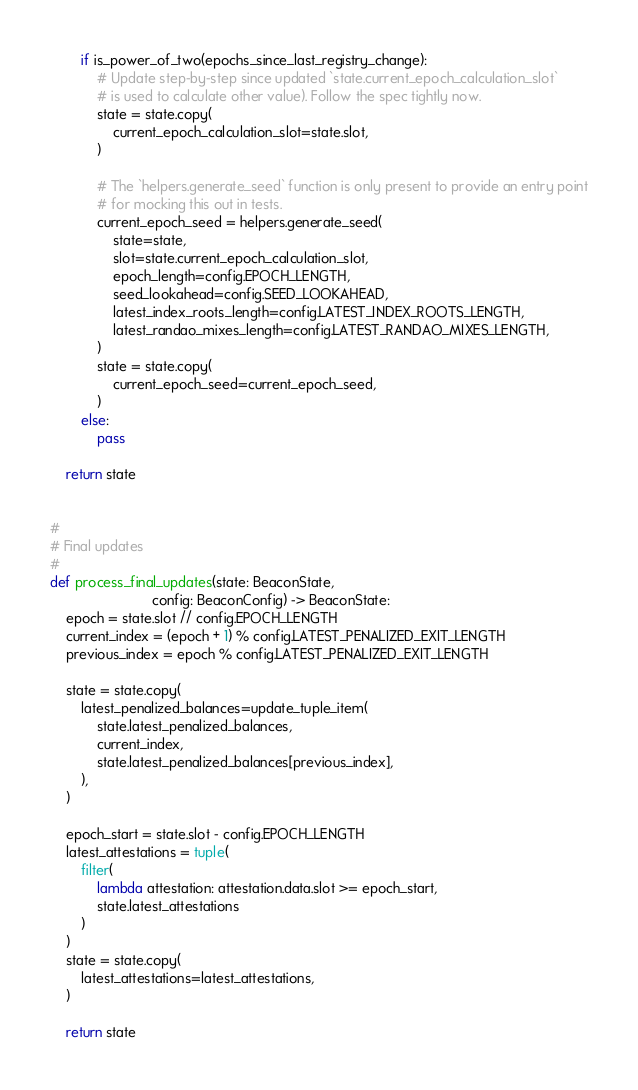<code> <loc_0><loc_0><loc_500><loc_500><_Python_>        if is_power_of_two(epochs_since_last_registry_change):
            # Update step-by-step since updated `state.current_epoch_calculation_slot`
            # is used to calculate other value). Follow the spec tightly now.
            state = state.copy(
                current_epoch_calculation_slot=state.slot,
            )

            # The `helpers.generate_seed` function is only present to provide an entry point
            # for mocking this out in tests.
            current_epoch_seed = helpers.generate_seed(
                state=state,
                slot=state.current_epoch_calculation_slot,
                epoch_length=config.EPOCH_LENGTH,
                seed_lookahead=config.SEED_LOOKAHEAD,
                latest_index_roots_length=config.LATEST_INDEX_ROOTS_LENGTH,
                latest_randao_mixes_length=config.LATEST_RANDAO_MIXES_LENGTH,
            )
            state = state.copy(
                current_epoch_seed=current_epoch_seed,
            )
        else:
            pass

    return state


#
# Final updates
#
def process_final_updates(state: BeaconState,
                          config: BeaconConfig) -> BeaconState:
    epoch = state.slot // config.EPOCH_LENGTH
    current_index = (epoch + 1) % config.LATEST_PENALIZED_EXIT_LENGTH
    previous_index = epoch % config.LATEST_PENALIZED_EXIT_LENGTH

    state = state.copy(
        latest_penalized_balances=update_tuple_item(
            state.latest_penalized_balances,
            current_index,
            state.latest_penalized_balances[previous_index],
        ),
    )

    epoch_start = state.slot - config.EPOCH_LENGTH
    latest_attestations = tuple(
        filter(
            lambda attestation: attestation.data.slot >= epoch_start,
            state.latest_attestations
        )
    )
    state = state.copy(
        latest_attestations=latest_attestations,
    )

    return state
</code> 